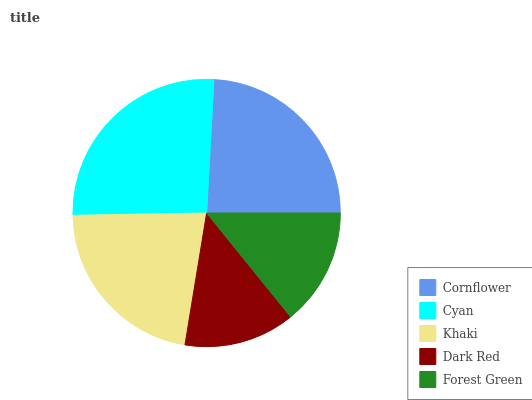Is Dark Red the minimum?
Answer yes or no. Yes. Is Cyan the maximum?
Answer yes or no. Yes. Is Khaki the minimum?
Answer yes or no. No. Is Khaki the maximum?
Answer yes or no. No. Is Cyan greater than Khaki?
Answer yes or no. Yes. Is Khaki less than Cyan?
Answer yes or no. Yes. Is Khaki greater than Cyan?
Answer yes or no. No. Is Cyan less than Khaki?
Answer yes or no. No. Is Khaki the high median?
Answer yes or no. Yes. Is Khaki the low median?
Answer yes or no. Yes. Is Cornflower the high median?
Answer yes or no. No. Is Cornflower the low median?
Answer yes or no. No. 